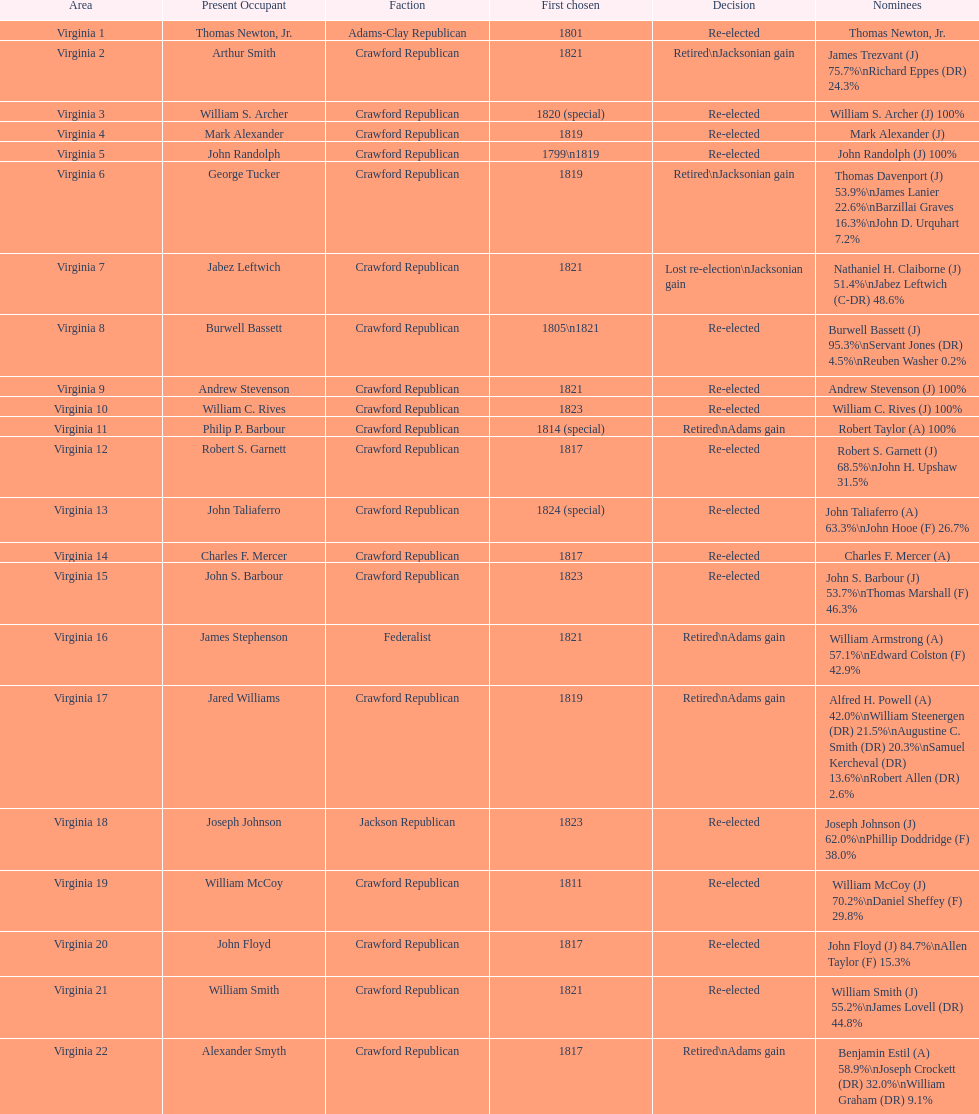What is the last party on this chart? Crawford Republican. 